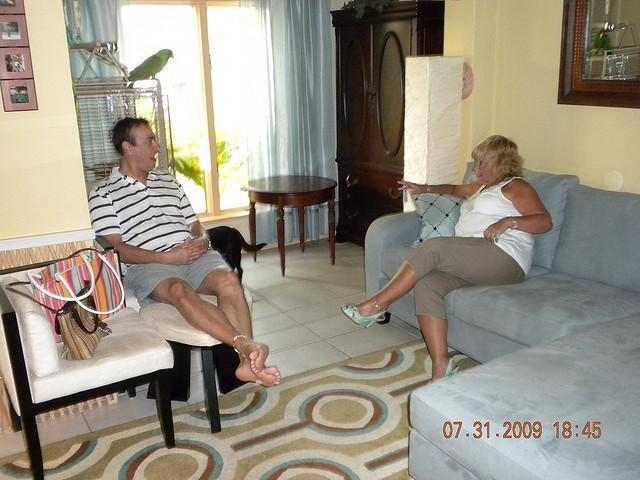Does the description: "The bird is toward the couch." accurately reflect the image?
Answer yes or no. Yes. 